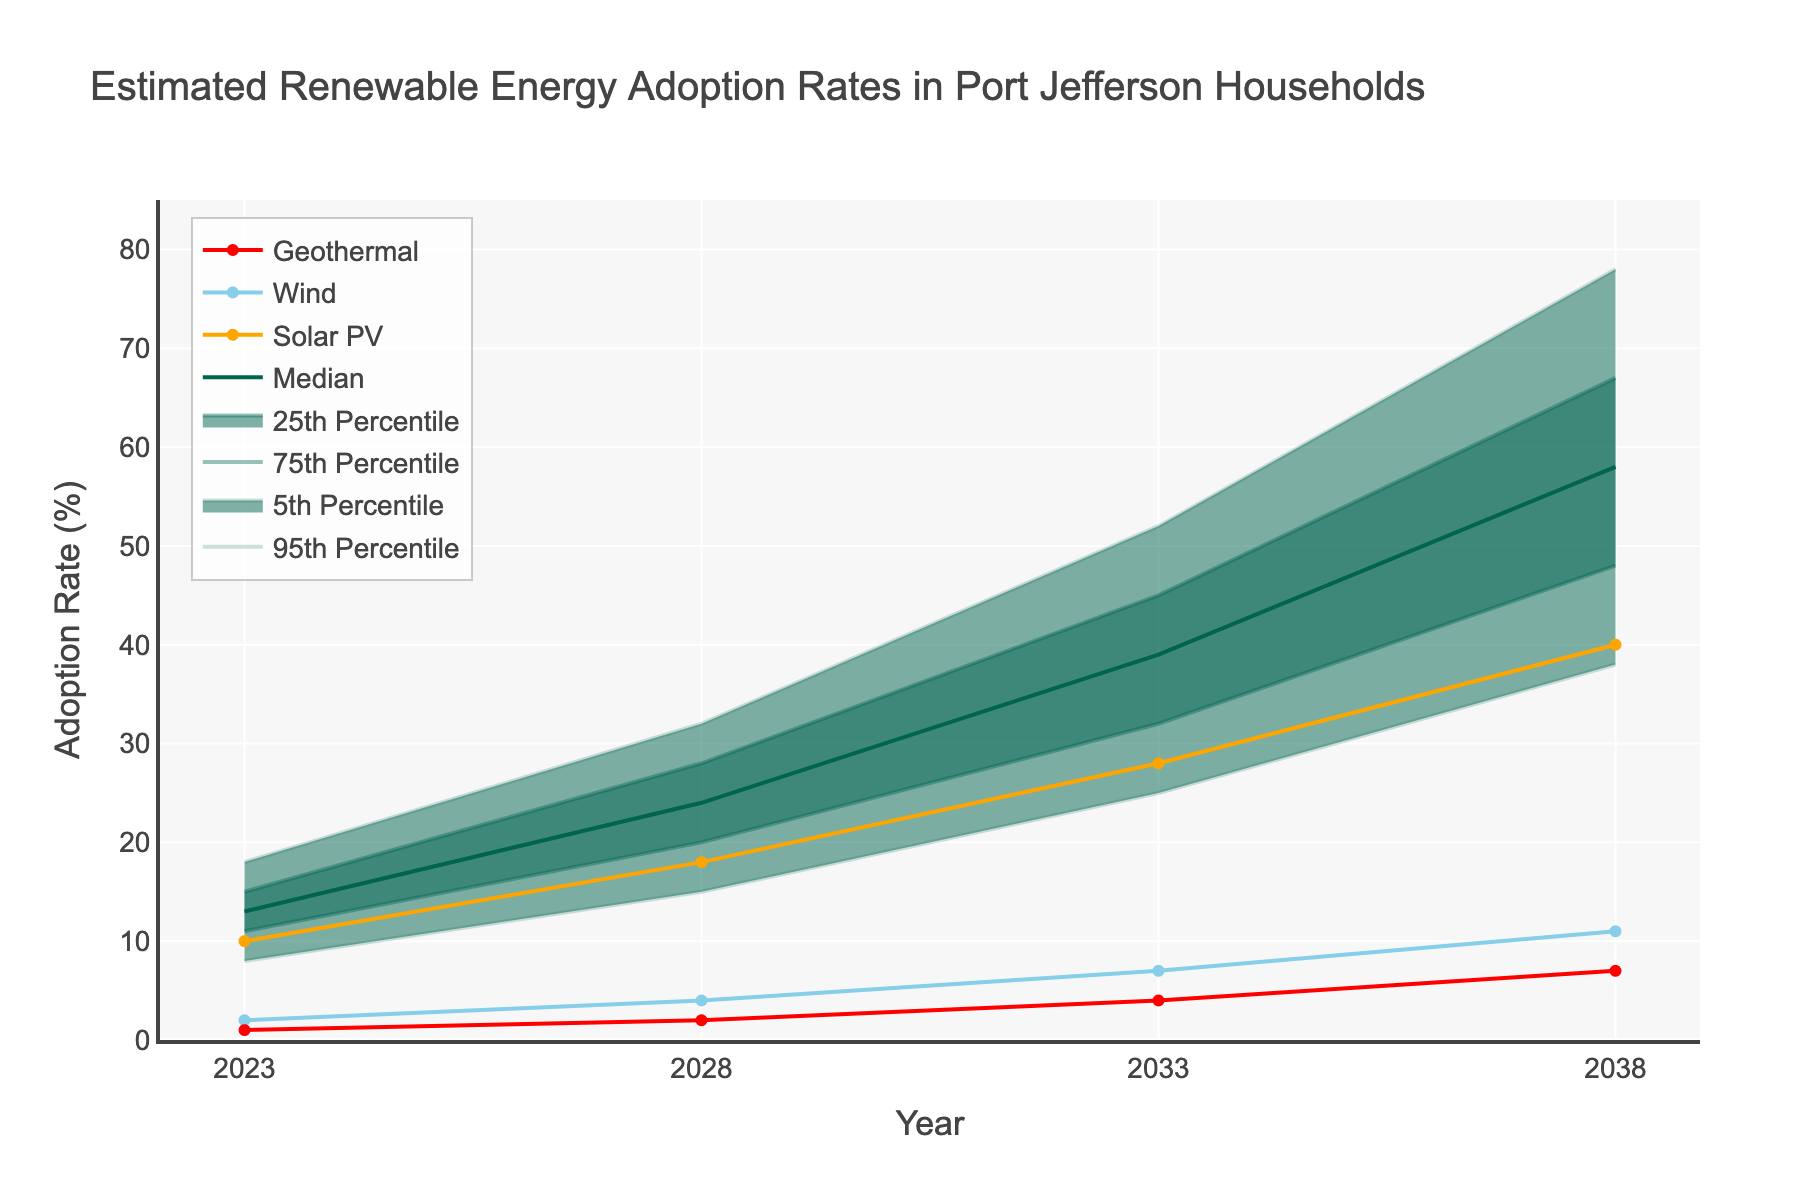What is the title of the chart? The title is written at the top of the chart.
Answer: Estimated Renewable Energy Adoption Rates in Port Jefferson Households Which year has the highest median adoption rate? Look at the line representing the median and identify the highest point on the y-axis.
Answer: 2038 What is the adoption rate for Wind technology in 2028? Locate the marker for Wind technology in the year 2028 on the x-axis and read the corresponding y-axis value.
Answer: 4% Which technology is projected to have the highest adoption rate in 2038? Compare the y-axis values for Solar PV, Wind, and Geothermal in the year 2038.
Answer: Solar PV How much does the adoption rate for Solar PV increase from 2023 to 2038? Subtract the Solar PV value in 2023 from the Solar PV value in 2038.
Answer: 30% What is the range of adoption rates for the 75th percentile in 2033? Find the 75th percentile value for 2033 on the y-axis.
Answer: 45% Which percentile band is the widest in 2038? Compare the distances between the 5th and 95th percentiles in 2038 on the y-axis.
Answer: 5th to 95th Percentile How many data points are displayed in the graph? Count the number of years shown on the x-axis.
Answer: 4 (2023, 2028, 2033, 2038) Which technology shows the slowest growth over the 15 years? Compare the growth rates of Solar PV, Wind, and Geothermal from 2023 to 2038.
Answer: Geothermal What does the shaded area between the 5th and 95th percentiles represent? Interpret the fan chart and explain the probable range of adoption rates.
Answer: The 90% confidence interval for adoption rates 